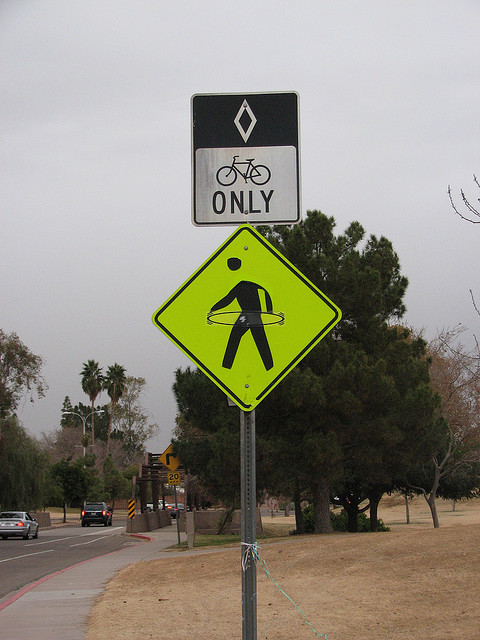<image>What does the left sign say? I am unsure about what the left sign says. It might say "only", "surfboard", "turn right", "bikes only", or "slow". What does the left sign say? I don't know what the left sign says. It can be either 'unknown', 'only', 'surfboard', 'turn right', 'bikes only', 'slow' or 'bikes only'. 